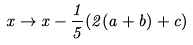<formula> <loc_0><loc_0><loc_500><loc_500>x \rightarrow x - \frac { 1 } { 5 } ( 2 ( a + b ) + c )</formula> 